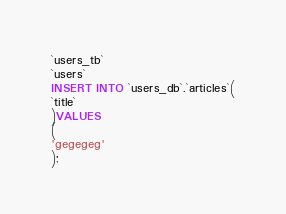Convert code to text. <code><loc_0><loc_0><loc_500><loc_500><_SQL_>`users_tb`
`users`
INSERT INTO `users_db`.`articles`(
`title`
)VALUES
(
'gegegeg'
);


</code> 